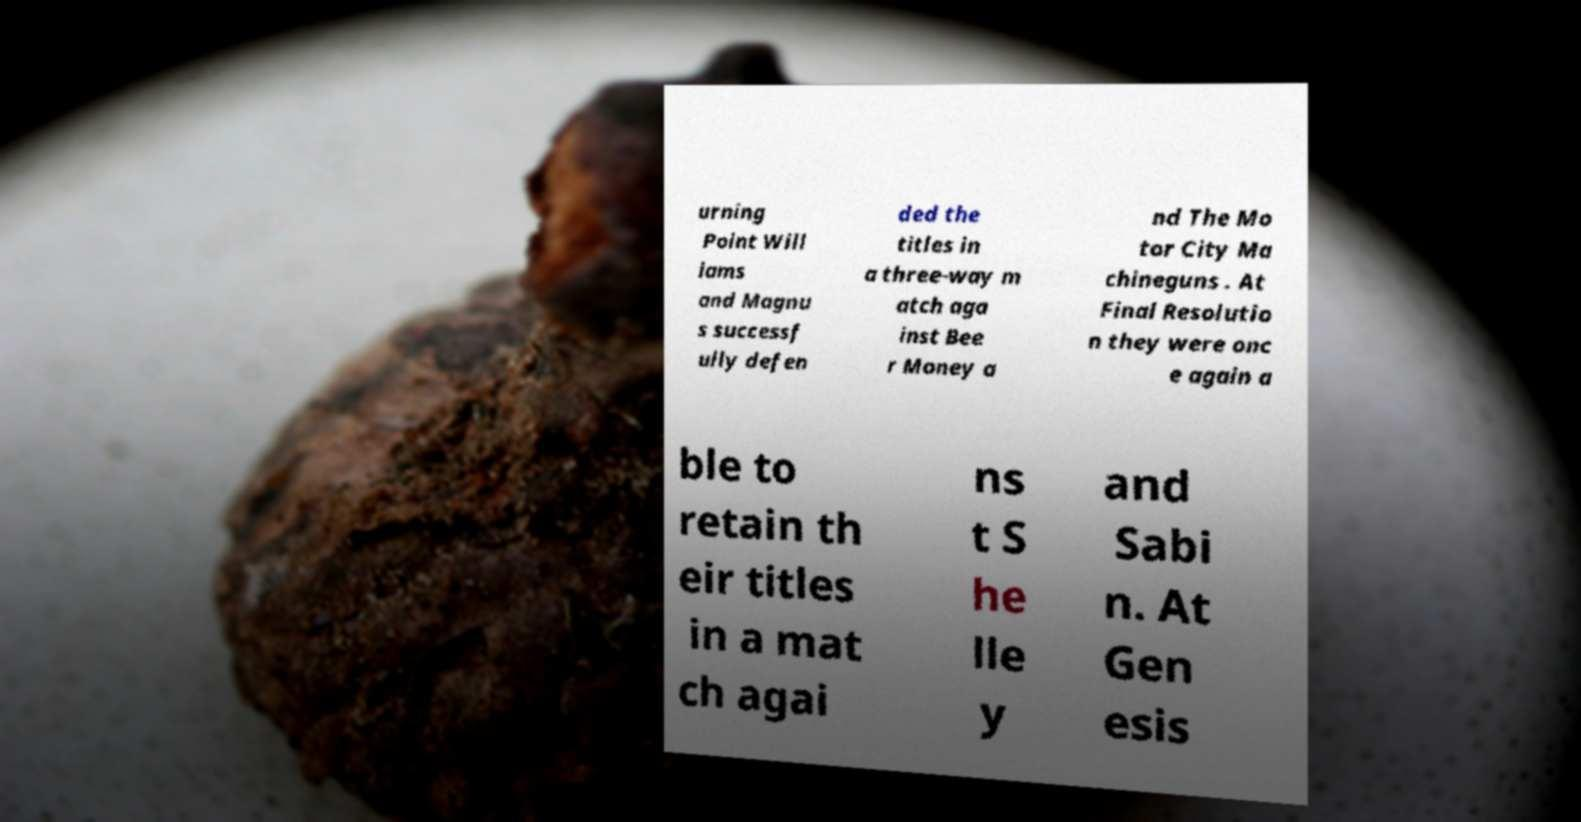Please read and relay the text visible in this image. What does it say? urning Point Will iams and Magnu s successf ully defen ded the titles in a three-way m atch aga inst Bee r Money a nd The Mo tor City Ma chineguns . At Final Resolutio n they were onc e again a ble to retain th eir titles in a mat ch agai ns t S he lle y and Sabi n. At Gen esis 